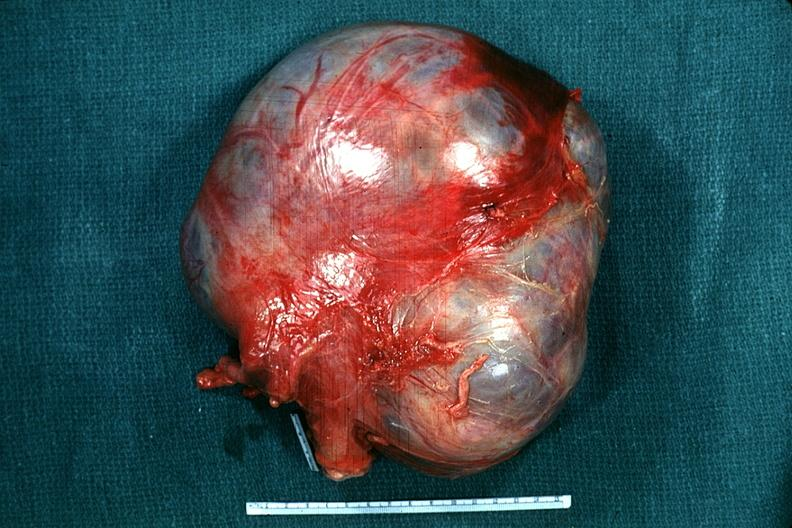s female reproductive present?
Answer the question using a single word or phrase. Yes 